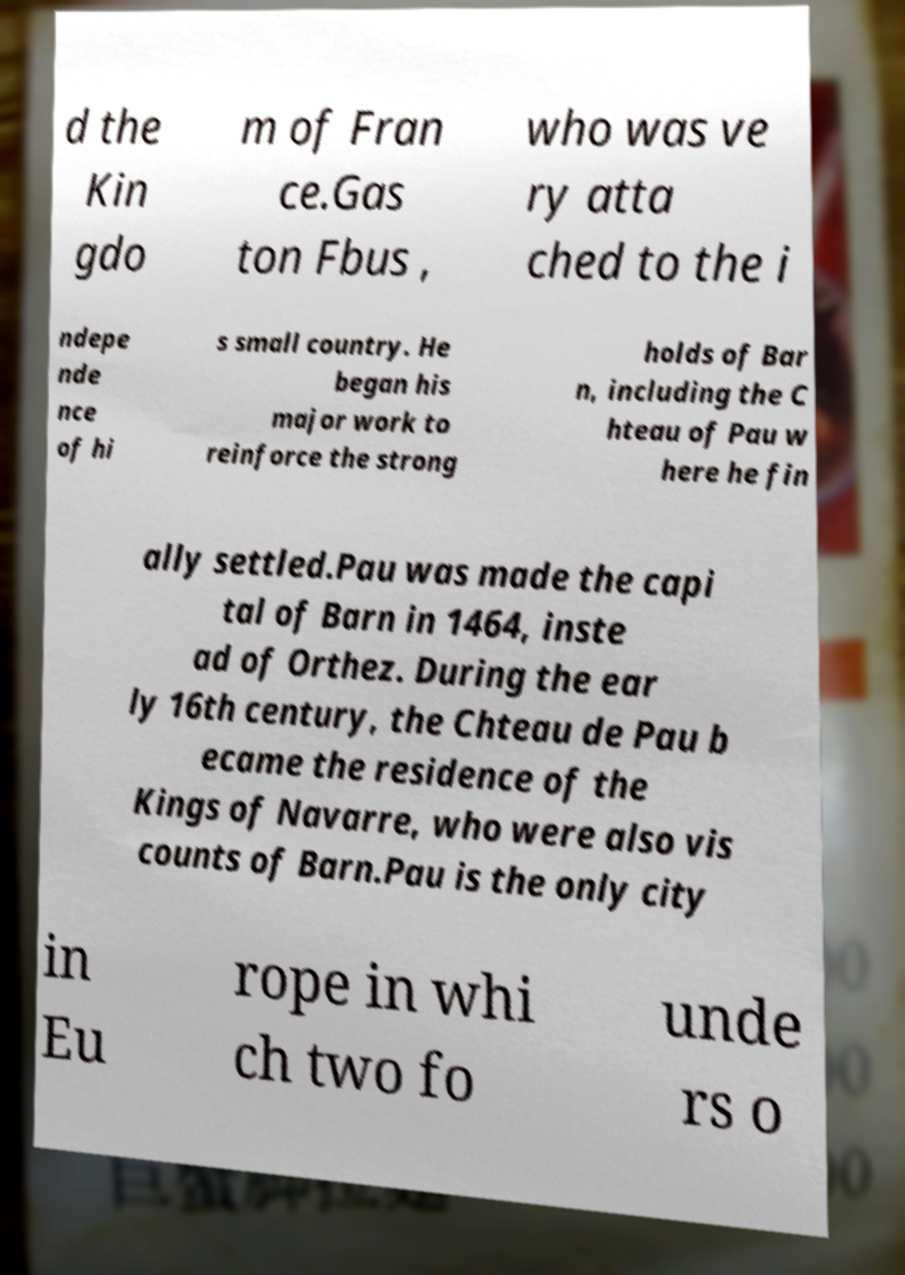For documentation purposes, I need the text within this image transcribed. Could you provide that? d the Kin gdo m of Fran ce.Gas ton Fbus , who was ve ry atta ched to the i ndepe nde nce of hi s small country. He began his major work to reinforce the strong holds of Bar n, including the C hteau of Pau w here he fin ally settled.Pau was made the capi tal of Barn in 1464, inste ad of Orthez. During the ear ly 16th century, the Chteau de Pau b ecame the residence of the Kings of Navarre, who were also vis counts of Barn.Pau is the only city in Eu rope in whi ch two fo unde rs o 